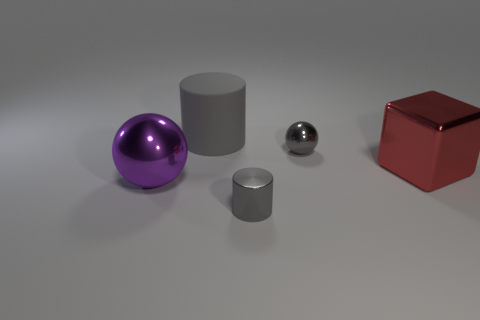What material is the cube that is the same size as the purple metallic object?
Your response must be concise. Metal. What number of objects are either tiny gray shiny objects that are in front of the purple sphere or large objects that are in front of the matte object?
Your answer should be very brief. 3. Is there a big red metallic thing that has the same shape as the purple metal object?
Keep it short and to the point. No. There is a big thing that is the same color as the small metal ball; what material is it?
Provide a short and direct response. Rubber. What number of rubber things are large red things or big spheres?
Ensure brevity in your answer.  0. The purple object has what shape?
Your answer should be compact. Sphere. What number of gray cylinders have the same material as the large red object?
Provide a short and direct response. 1. There is a big cube that is made of the same material as the purple object; what color is it?
Make the answer very short. Red. Is the size of the red cube behind the purple thing the same as the small cylinder?
Your answer should be compact. No. There is another metal object that is the same shape as the purple thing; what color is it?
Provide a short and direct response. Gray. 